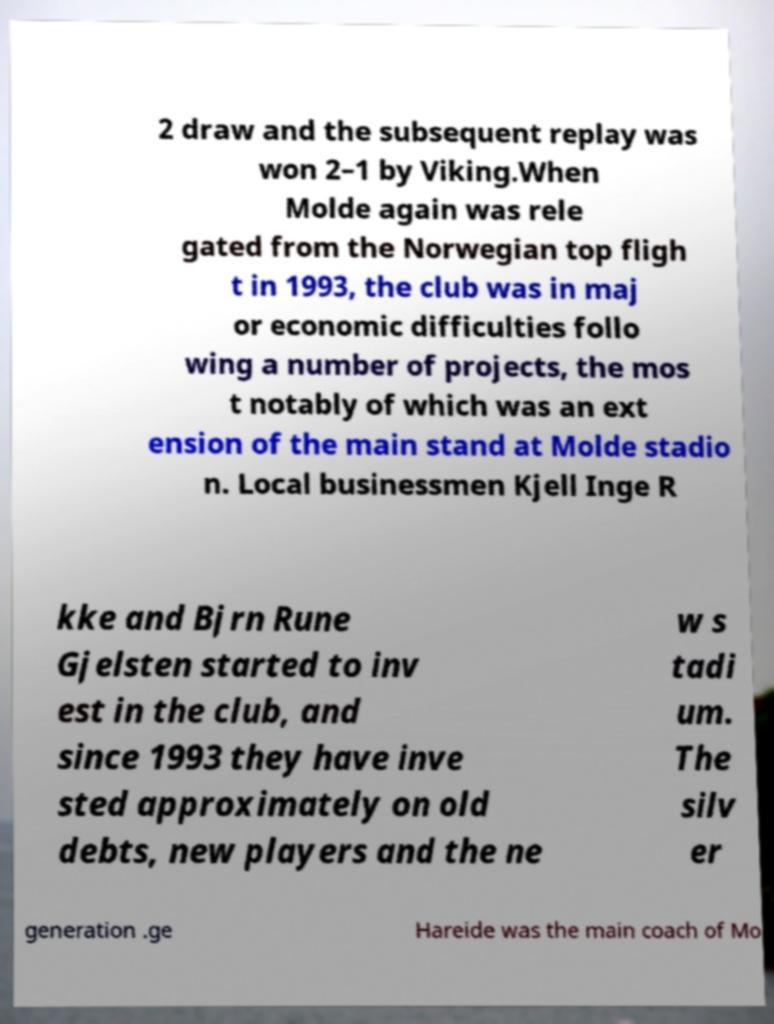Please identify and transcribe the text found in this image. 2 draw and the subsequent replay was won 2–1 by Viking.When Molde again was rele gated from the Norwegian top fligh t in 1993, the club was in maj or economic difficulties follo wing a number of projects, the mos t notably of which was an ext ension of the main stand at Molde stadio n. Local businessmen Kjell Inge R kke and Bjrn Rune Gjelsten started to inv est in the club, and since 1993 they have inve sted approximately on old debts, new players and the ne w s tadi um. The silv er generation .ge Hareide was the main coach of Mo 